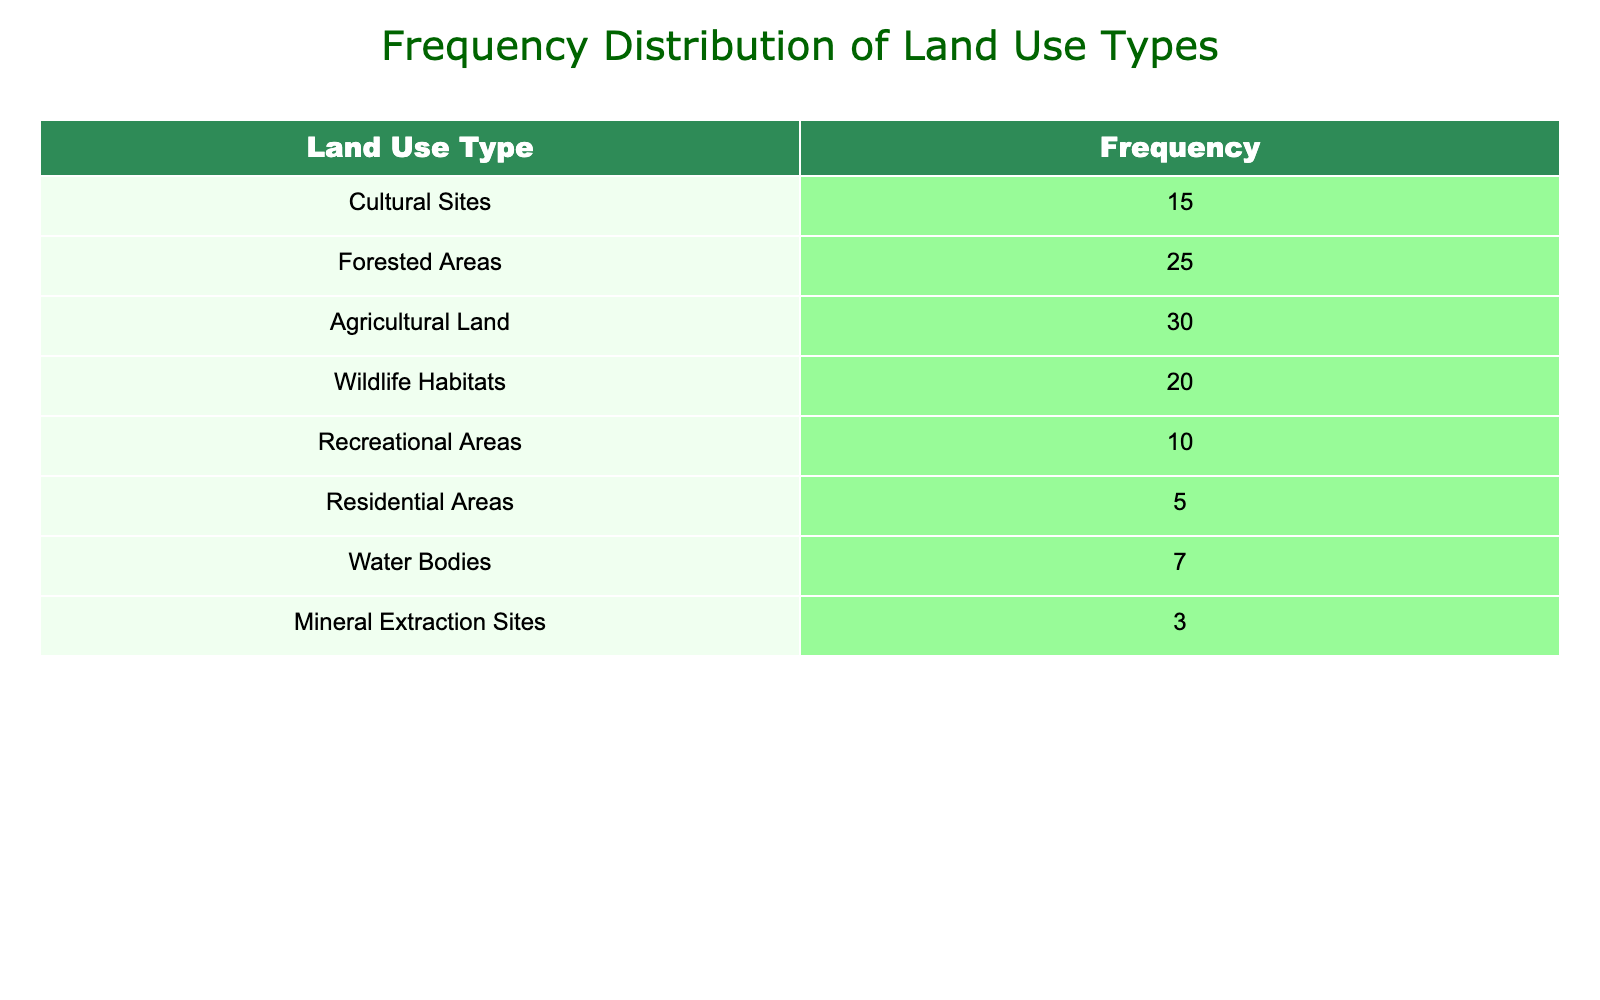What is the frequency of Agricultural Land use? The table states that the frequency for Agricultural Land is explicitly listed, so we can directly refer to that value.
Answer: 30 Which land use type has the least frequency? By examining the table, we look for the smallest value among the frequencies, which is 3 for Mineral Extraction Sites.
Answer: Mineral Extraction Sites What is the sum of frequencies for Cultural Sites and Recreational Areas? We find the frequencies for Cultural Sites (15) and Recreational Areas (10). Then, we add these two values together: 15 + 10 = 25.
Answer: 25 Is the frequency of Wildlife Habitats greater than that of Residential Areas? The frequency of Wildlife Habitats is 20, whereas Residential Areas has a frequency of 5. Since 20 is greater than 5, the statement is true.
Answer: Yes What is the average frequency of all land use types listed in the table? To find the average, we first sum all frequency values: 15 + 25 + 30 + 20 + 10 + 5 + 7 + 3 = 115. There are 8 land use types in total. Thus, we divide the total by the number of types: 115 / 8 = 14.375.
Answer: 14.375 What is the difference in frequency between Forested Areas and Wildlife Habitats? The frequency for Forested Areas is 25 and for Wildlife Habitats is 20. We calculate the difference by subtracting the frequency of Wildlife Habitats from that of Forested Areas: 25 - 20 = 5.
Answer: 5 How many more frequencies are occupied by Agricultural Land than Recreational Areas? The frequency for Agricultural Land is 30 and for Recreational Areas is 10. We calculate the difference: 30 - 10 = 20, indicating that Agricultural Land has significantly more.
Answer: 20 Is there a land use type with a frequency of exactly 7? We can check the table to see if any land use type has a frequency value of 7. The Water Bodies category has this exact frequency.
Answer: Yes What is the combined frequency of all land use types except Residential Areas? We sum the frequencies for all types and then subtract the frequency of Residential Areas: 115 (total) - 5 (Residential Areas) = 110.
Answer: 110 